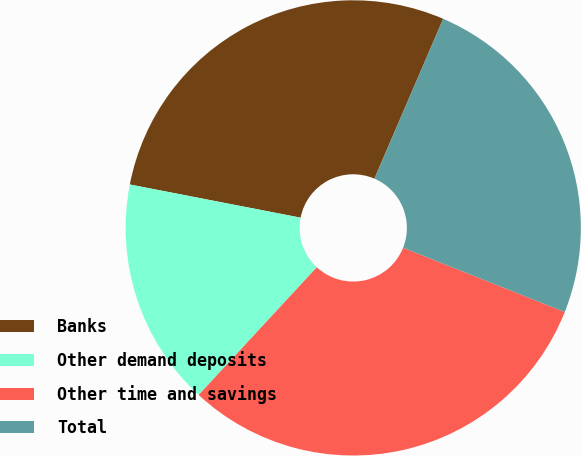Convert chart. <chart><loc_0><loc_0><loc_500><loc_500><pie_chart><fcel>Banks<fcel>Other demand deposits<fcel>Other time and savings<fcel>Total<nl><fcel>28.41%<fcel>16.17%<fcel>30.86%<fcel>24.56%<nl></chart> 